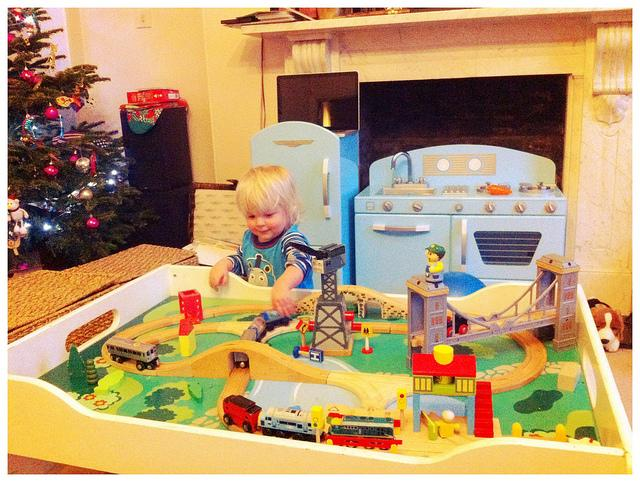What is the child playing with? train 